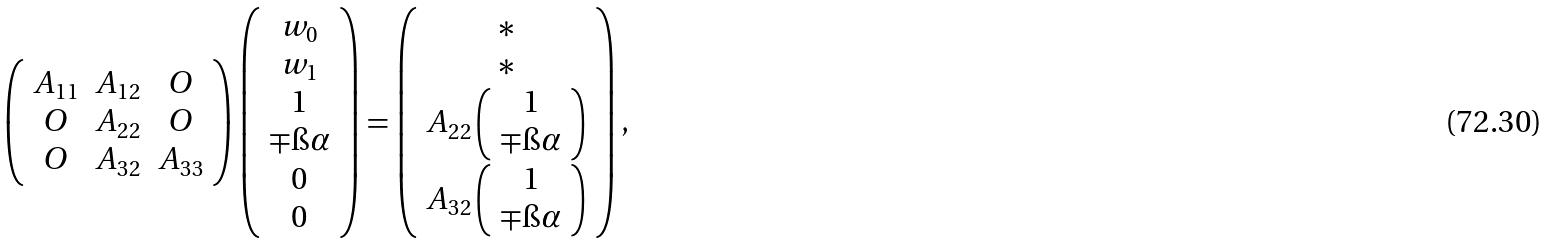<formula> <loc_0><loc_0><loc_500><loc_500>\left ( \begin{array} { c c c } A _ { 1 1 } & A _ { 1 2 } & O \\ O & A _ { 2 2 } & O \\ O & A _ { 3 2 } & A _ { 3 3 } \end{array} \right ) \left ( \begin{array} { c } w _ { 0 } \\ w _ { 1 } \\ 1 \\ \mp \i \alpha \\ 0 \\ 0 \end{array} \right ) = \left ( \begin{array} { c } \ast \\ \ast \\ A _ { 2 2 } \left ( \begin{array} { c } 1 \\ \mp \i \alpha \end{array} \right ) \\ A _ { 3 2 } \left ( \begin{array} { c } 1 \\ \mp \i \alpha \end{array} \right ) \end{array} \right ) ,</formula> 